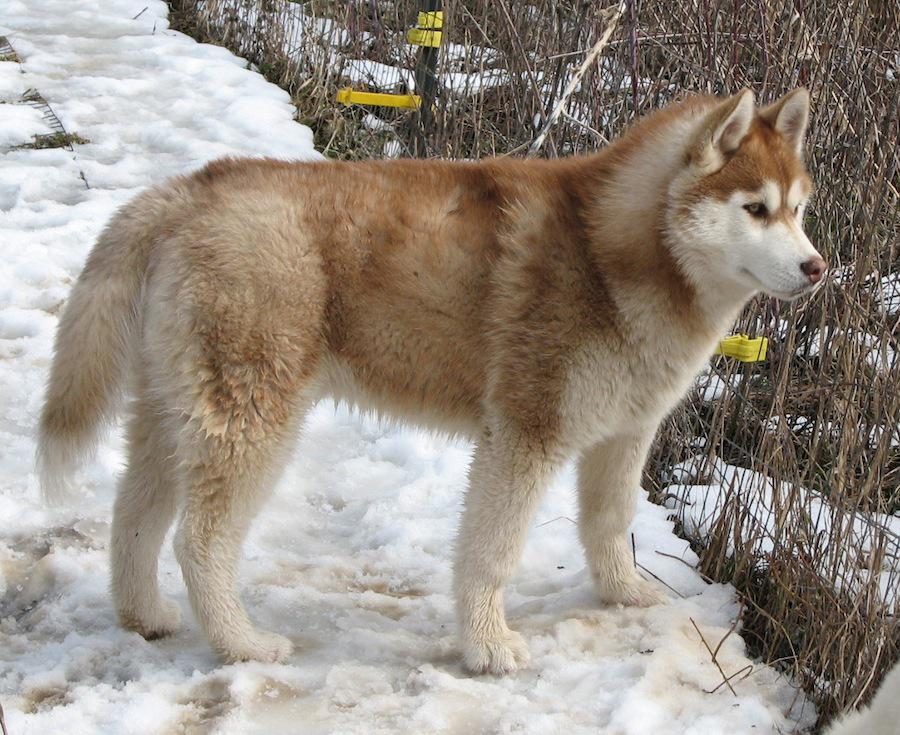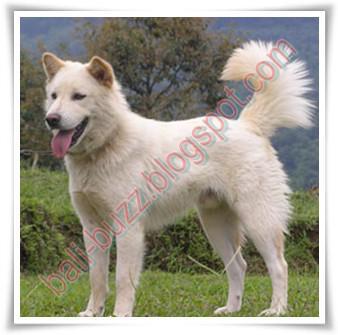The first image is the image on the left, the second image is the image on the right. For the images shown, is this caption "An image shows two adult huskies reclining side-by-side in the snow, with a dusting of snow on their fur." true? Answer yes or no. No. The first image is the image on the left, the second image is the image on the right. Considering the images on both sides, is "There is one dog who is not in the snow." valid? Answer yes or no. Yes. 